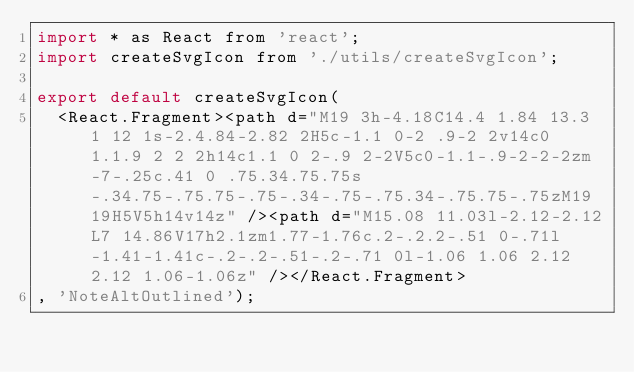Convert code to text. <code><loc_0><loc_0><loc_500><loc_500><_JavaScript_>import * as React from 'react';
import createSvgIcon from './utils/createSvgIcon';

export default createSvgIcon(
  <React.Fragment><path d="M19 3h-4.18C14.4 1.84 13.3 1 12 1s-2.4.84-2.82 2H5c-1.1 0-2 .9-2 2v14c0 1.1.9 2 2 2h14c1.1 0 2-.9 2-2V5c0-1.1-.9-2-2-2zm-7-.25c.41 0 .75.34.75.75s-.34.75-.75.75-.75-.34-.75-.75.34-.75.75-.75zM19 19H5V5h14v14z" /><path d="M15.08 11.03l-2.12-2.12L7 14.86V17h2.1zm1.77-1.76c.2-.2.2-.51 0-.71l-1.41-1.41c-.2-.2-.51-.2-.71 0l-1.06 1.06 2.12 2.12 1.06-1.06z" /></React.Fragment>
, 'NoteAltOutlined');
</code> 